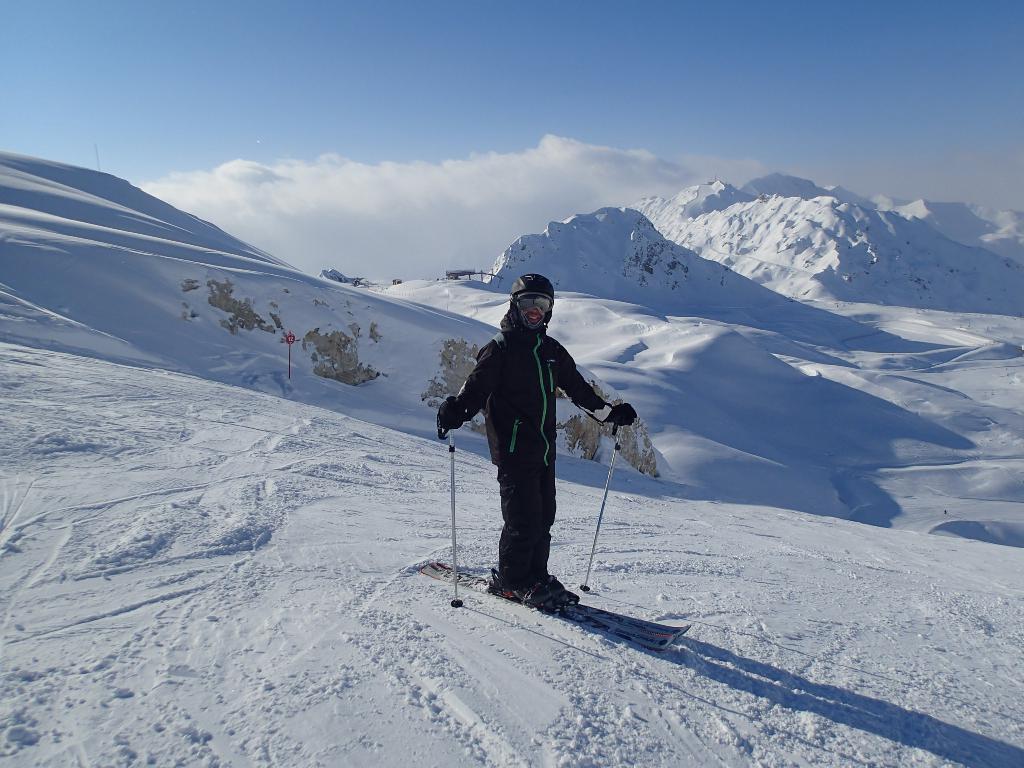Could you give a brief overview of what you see in this image? In this image I can see ground full of snow and on it I can see a person is standing on skis. I can see that person is holding sticks and I can see that person is wearing black dress, glasses and helmet. I can also see shadow over here and in background I can see mountains, clouds and the sky. 